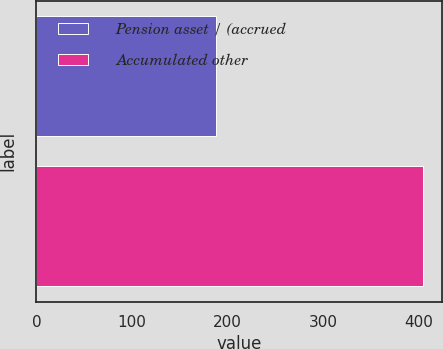<chart> <loc_0><loc_0><loc_500><loc_500><bar_chart><fcel>Pension asset / (accrued<fcel>Accumulated other<nl><fcel>188<fcel>405<nl></chart> 